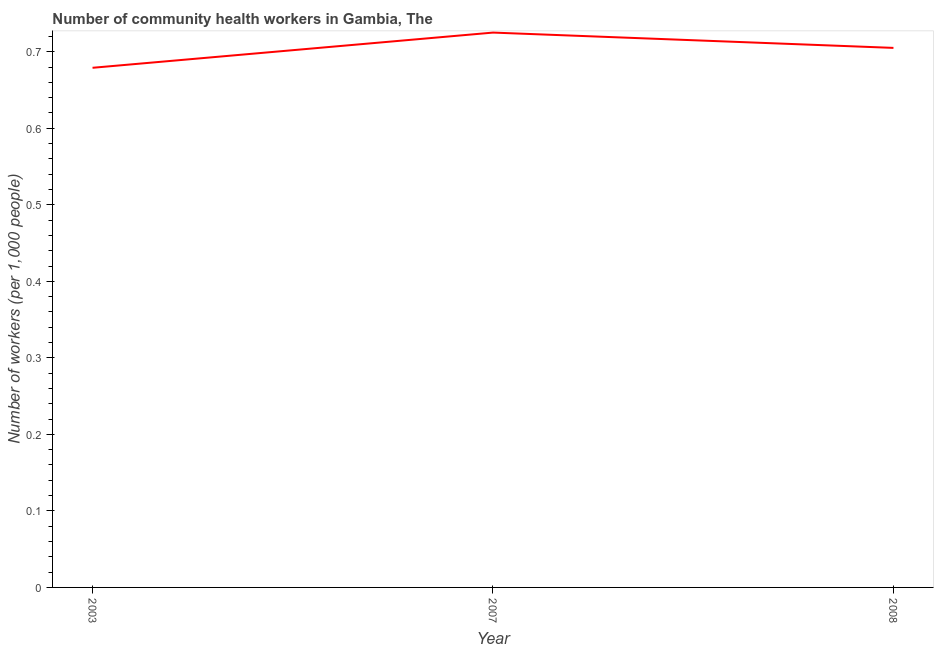What is the number of community health workers in 2003?
Your answer should be very brief. 0.68. Across all years, what is the maximum number of community health workers?
Give a very brief answer. 0.72. Across all years, what is the minimum number of community health workers?
Make the answer very short. 0.68. In which year was the number of community health workers maximum?
Keep it short and to the point. 2007. In which year was the number of community health workers minimum?
Offer a terse response. 2003. What is the sum of the number of community health workers?
Your response must be concise. 2.11. What is the difference between the number of community health workers in 2007 and 2008?
Give a very brief answer. 0.02. What is the average number of community health workers per year?
Your answer should be very brief. 0.7. What is the median number of community health workers?
Your answer should be compact. 0.7. What is the ratio of the number of community health workers in 2003 to that in 2007?
Provide a short and direct response. 0.94. Is the number of community health workers in 2003 less than that in 2007?
Keep it short and to the point. Yes. Is the difference between the number of community health workers in 2007 and 2008 greater than the difference between any two years?
Keep it short and to the point. No. What is the difference between the highest and the second highest number of community health workers?
Offer a terse response. 0.02. What is the difference between the highest and the lowest number of community health workers?
Your answer should be very brief. 0.05. What is the difference between two consecutive major ticks on the Y-axis?
Give a very brief answer. 0.1. Does the graph contain any zero values?
Keep it short and to the point. No. Does the graph contain grids?
Provide a short and direct response. No. What is the title of the graph?
Your answer should be compact. Number of community health workers in Gambia, The. What is the label or title of the X-axis?
Your answer should be compact. Year. What is the label or title of the Y-axis?
Your response must be concise. Number of workers (per 1,0 people). What is the Number of workers (per 1,000 people) of 2003?
Ensure brevity in your answer.  0.68. What is the Number of workers (per 1,000 people) in 2007?
Provide a short and direct response. 0.72. What is the Number of workers (per 1,000 people) in 2008?
Your response must be concise. 0.7. What is the difference between the Number of workers (per 1,000 people) in 2003 and 2007?
Your answer should be very brief. -0.05. What is the difference between the Number of workers (per 1,000 people) in 2003 and 2008?
Give a very brief answer. -0.03. What is the ratio of the Number of workers (per 1,000 people) in 2003 to that in 2007?
Your answer should be very brief. 0.94. What is the ratio of the Number of workers (per 1,000 people) in 2007 to that in 2008?
Offer a very short reply. 1.03. 